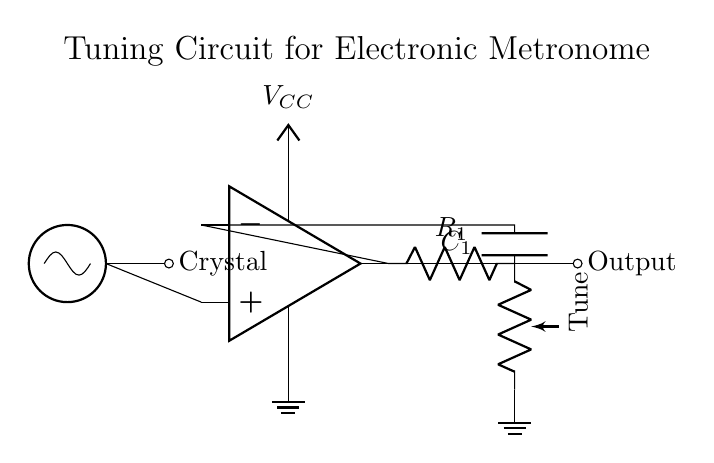What type of circuit is depicted? The circuit is an oscillator circuit, which is used to generate a periodic signal, commonly needed for metronomes. This can be identified by the presence of an op-amp and a crystal oscillator.
Answer: oscillator circuit What is the role of the crystal in this circuit? The crystal serves as a frequency reference, helping to maintain a precise frequency of oscillation in the circuit. This is crucial for ensuring accurate tempo in a metronome.
Answer: frequency reference What component is used for fine-tuning the circuit? The component used for fine-tuning is a potentiometer, which allows for small adjustments to the circuit's tuning. This is indicated by the label "Tune" in the diagram.
Answer: potentiometer What is the function of the op-amp in this circuit? The op-amp amplifies the signal produced by the oscillator, making it strong enough to drive the output. This can be seen as the op-amp takes input from the oscillator and provides output after amplification.
Answer: amplifies the signal How many resistors are present in the feedback network? There is one resistor present in the feedback network, labeled R1, which connects the output of the op-amp back to its inverting input.
Answer: one What is the purpose of the capacitor in this circuit? The capacitor, labeled C1, is used in conjunction with the resistor in the feedback network to determine the frequency of oscillation, contributing to the tuning characteristics of the circuit.
Answer: determines frequency 